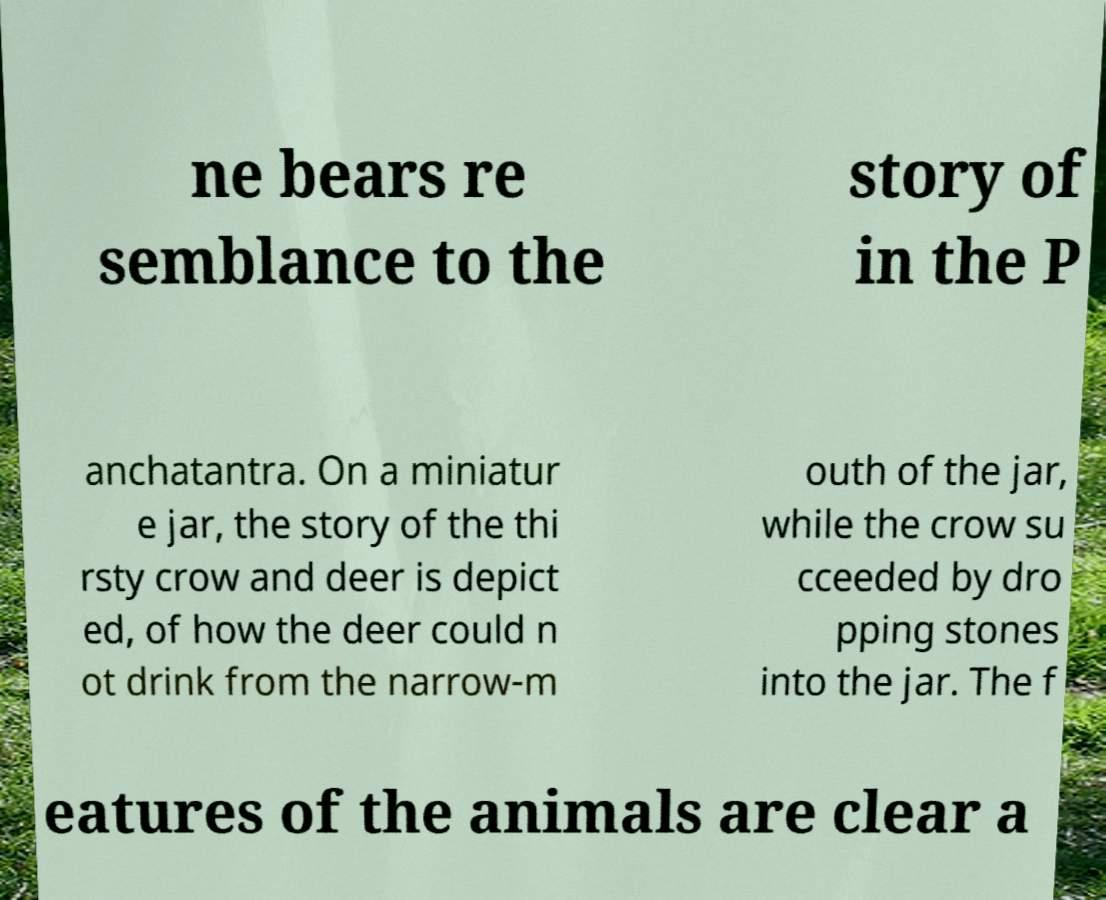Can you accurately transcribe the text from the provided image for me? ne bears re semblance to the story of in the P anchatantra. On a miniatur e jar, the story of the thi rsty crow and deer is depict ed, of how the deer could n ot drink from the narrow-m outh of the jar, while the crow su cceeded by dro pping stones into the jar. The f eatures of the animals are clear a 